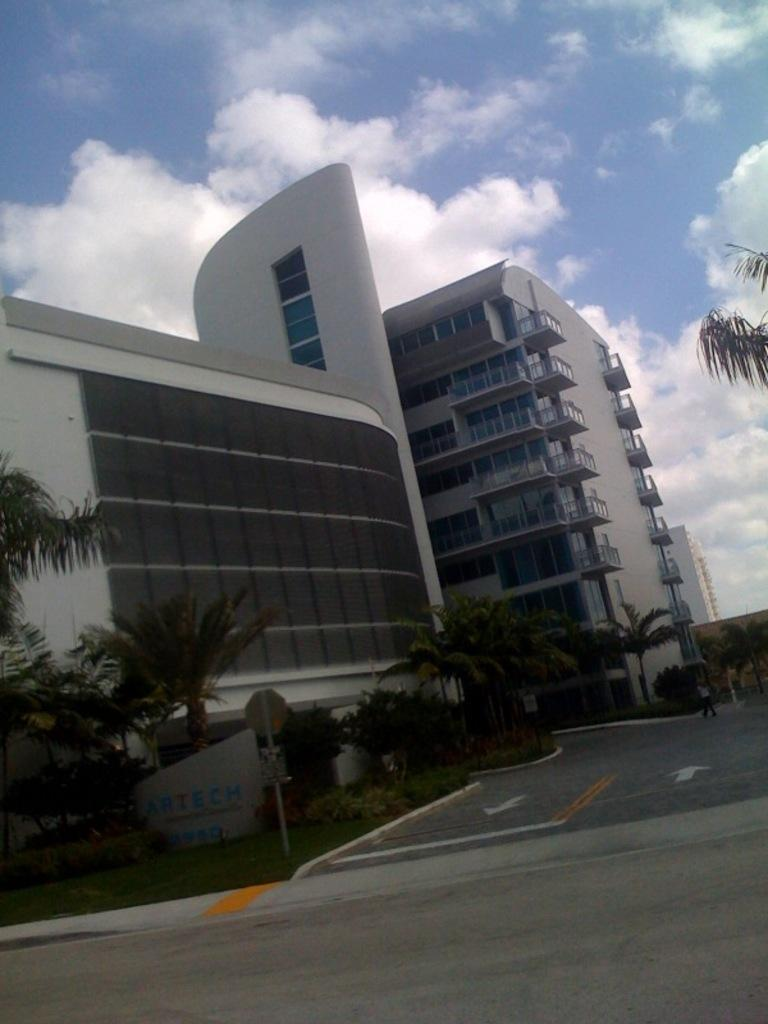What type of structures can be seen in the image? There are buildings in the image. What type of vegetation is present in the image? There are trees, bushes, and shrubs in the image. What type of man-made objects can be seen in the image? There are poles in the image. What is visible on the ground in the image? The ground is visible in the image, and there is a road present. What is used to identify a location in the image? There is a name board in the image. What is visible in the sky in the image? The sky is visible in the image, and there are clouds present. What is the rate of the current flowing through the trees in the image? There is no current flowing through the trees in the image, as they are not electrical conductors. What type of tool is used to rake the bushes in the image? There is no tool being used to rake the bushes in the image, as it is a still image and not an action scene. 